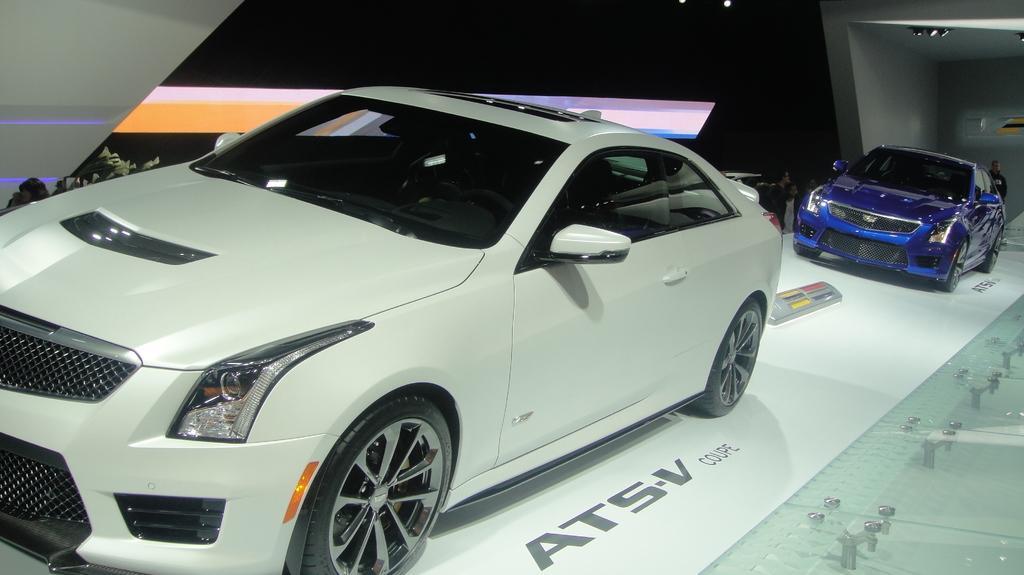Describe this image in one or two sentences. In this image we can see a few people and vehicles on the floor, on the roof, we can see some lights and there is a plant beside the vehicles. 